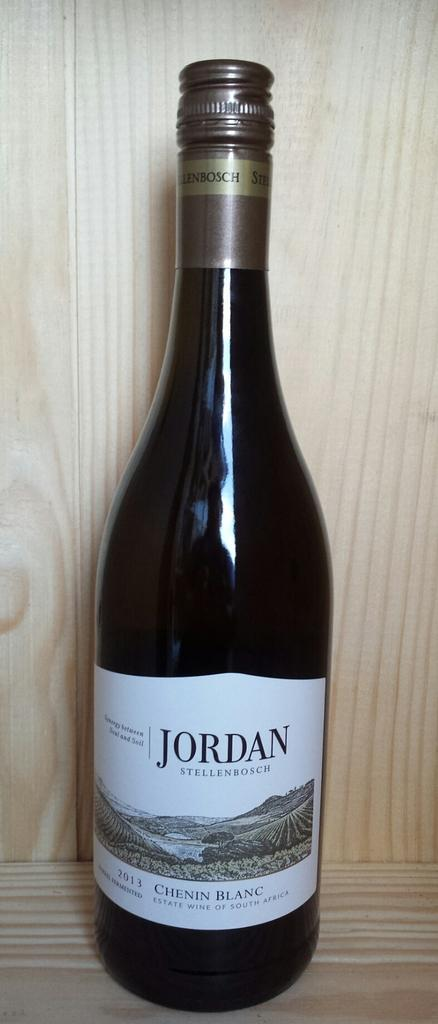<image>
Present a compact description of the photo's key features. A bottle of Jordan Chenin Blanc is displayed by itself. 